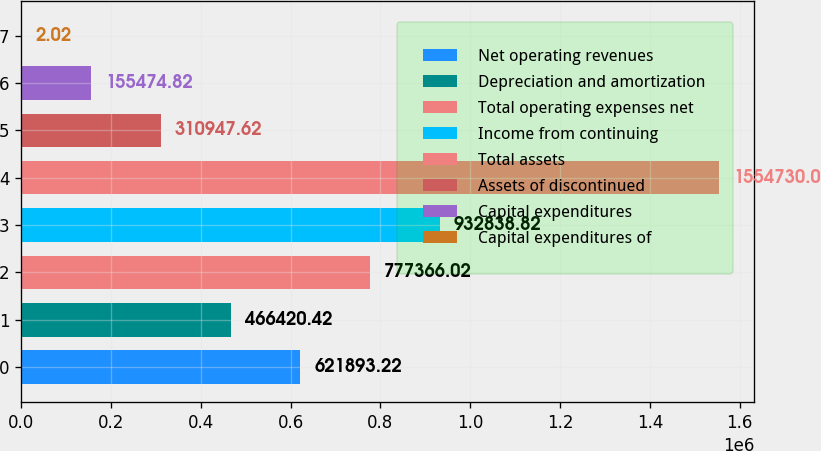Convert chart. <chart><loc_0><loc_0><loc_500><loc_500><bar_chart><fcel>Net operating revenues<fcel>Depreciation and amortization<fcel>Total operating expenses net<fcel>Income from continuing<fcel>Total assets<fcel>Assets of discontinued<fcel>Capital expenditures<fcel>Capital expenditures of<nl><fcel>621893<fcel>466420<fcel>777366<fcel>932839<fcel>1.55473e+06<fcel>310948<fcel>155475<fcel>2.02<nl></chart> 